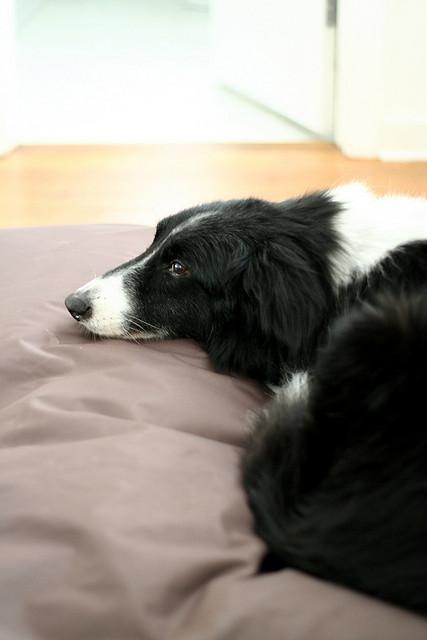How many people have their sunglasses pushed up onto their heads?
Give a very brief answer. 0. 